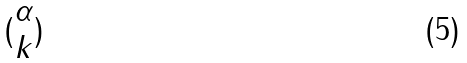Convert formula to latex. <formula><loc_0><loc_0><loc_500><loc_500>( \begin{matrix} \alpha \\ k \end{matrix} )</formula> 